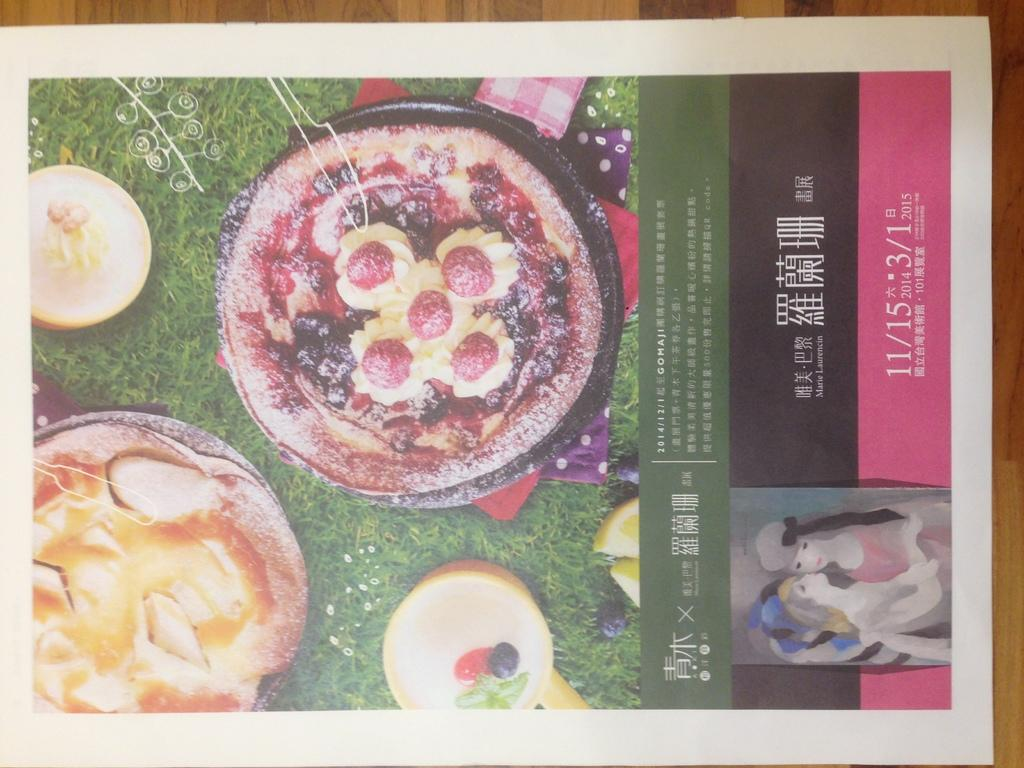<image>
Give a short and clear explanation of the subsequent image. A foreign poster with the dates 11/15/2014 and 3/1/2015. 